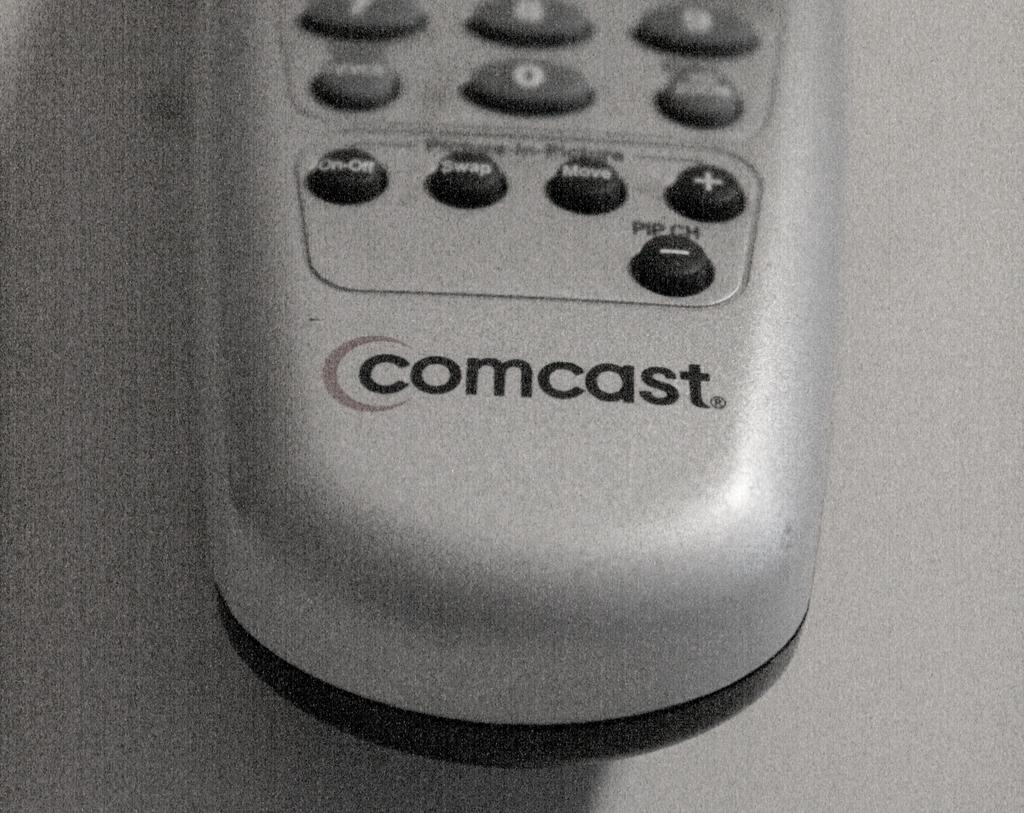<image>
Describe the image concisely. A silver comcast remote is set on a table. 